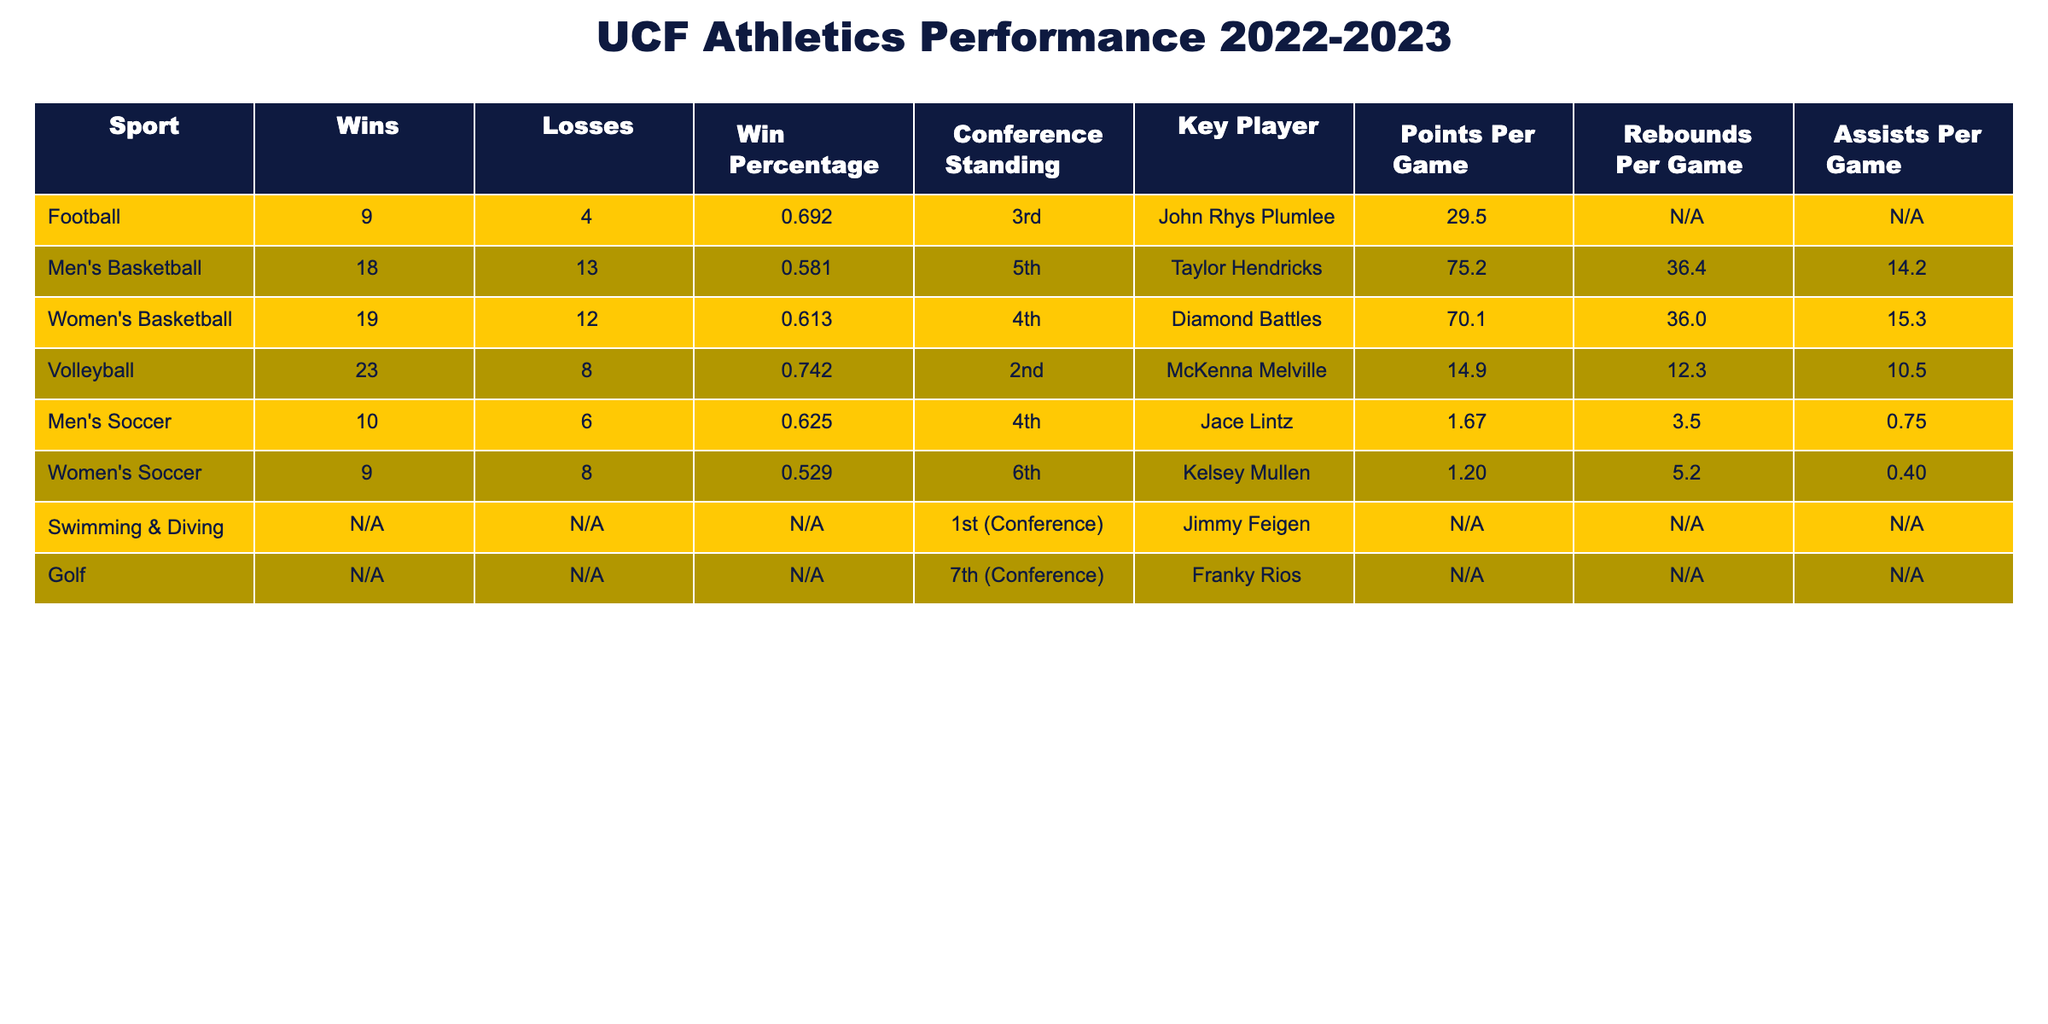What is the win percentage of the women's soccer team? The win percentage is listed in the table for the women's soccer team, which shows a win-loss record of 9 wins and 8 losses. The win percentage is calculated by dividing the number of wins by the total number of games played. Here, total games = 9 + 8 = 17, so the win percentage is 9/17 ≈ 0.529
Answer: 0.529 Who is the key player for men's basketball? The table directly states the key player for the men's basketball team as Taylor Hendricks.
Answer: Taylor Hendricks Which sport has the highest points per game? The points per game values for different sports are compared from the table. The volleyball team has the highest points per game at 14.9.
Answer: Volleyball What is the combined total wins for men's and women's basketball? The table shows 18 wins for men's basketball and 19 wins for women's basketball. Adding these together gives a total of 18 + 19 = 37 wins for both teams combined.
Answer: 37 Is swimming & diving the only sport listed without a win-loss record? Looking at the table, swimming & diving does not have wins or losses recorded, indicating it is the only sport without a win-loss record available. Therefore, the answer is yes.
Answer: Yes What is the average number of rebounds per game for the basketball teams? The rebounds per game for men's basketball is 36.4 and for women's basketball is 36.0. To find the average, sum these values: 36.4 + 36.0 = 72.4, then divide by 2, which equals 72.4/2 = 36.2.
Answer: 36.2 Did the volleyball team finish higher in the conference standing than the women's soccer team? The volleyball team is ranked 2nd in the conference standing while the women's soccer team is 6th, indicating that the volleyball team finished higher.
Answer: Yes How does the win percentage of the football team compare to that of the men's soccer team? The football team has a win percentage of 0.692, while the men's soccer team has a win percentage of 0.625. Comparing these values shows that the football team has a higher win percentage than the men's soccer team.
Answer: Football team has a higher win percentage 